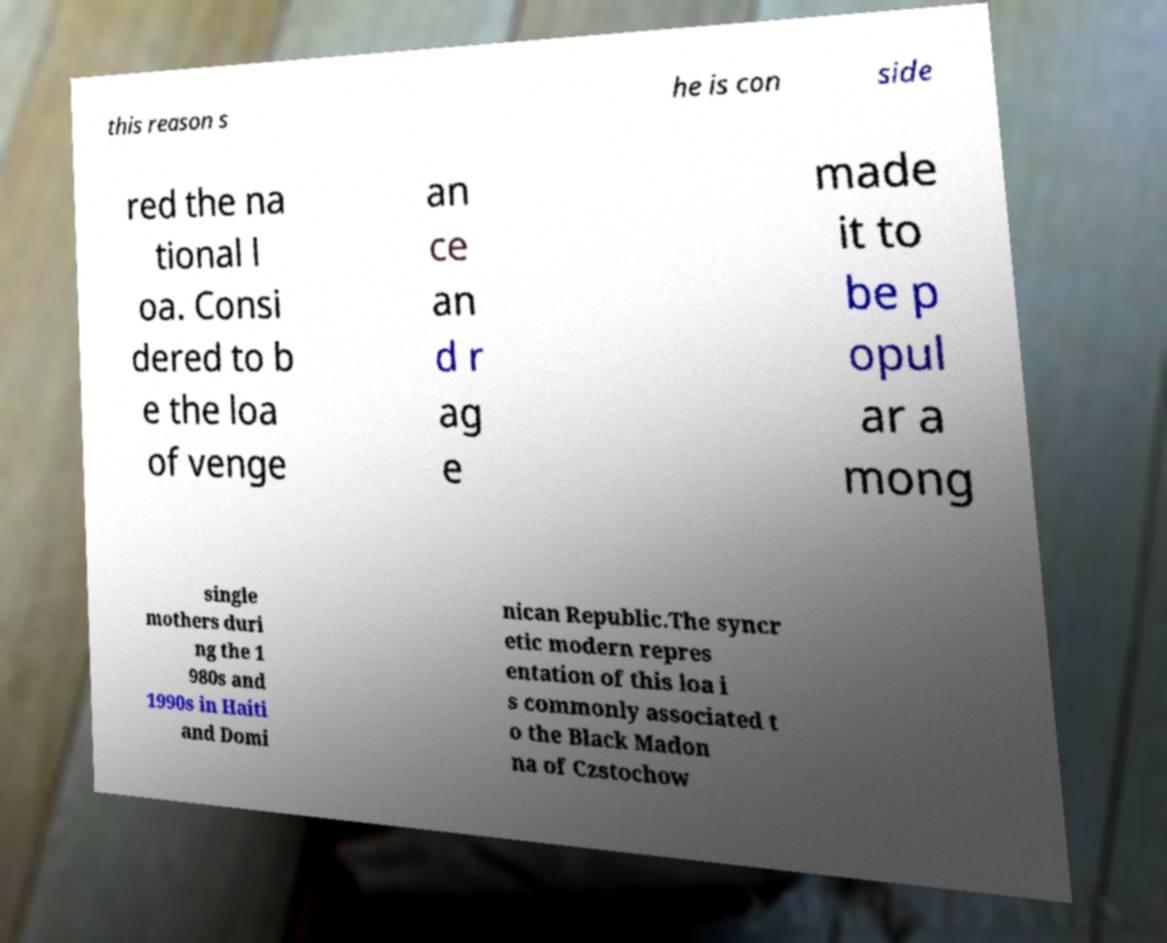For documentation purposes, I need the text within this image transcribed. Could you provide that? this reason s he is con side red the na tional l oa. Consi dered to b e the loa of venge an ce an d r ag e made it to be p opul ar a mong single mothers duri ng the 1 980s and 1990s in Haiti and Domi nican Republic.The syncr etic modern repres entation of this loa i s commonly associated t o the Black Madon na of Czstochow 